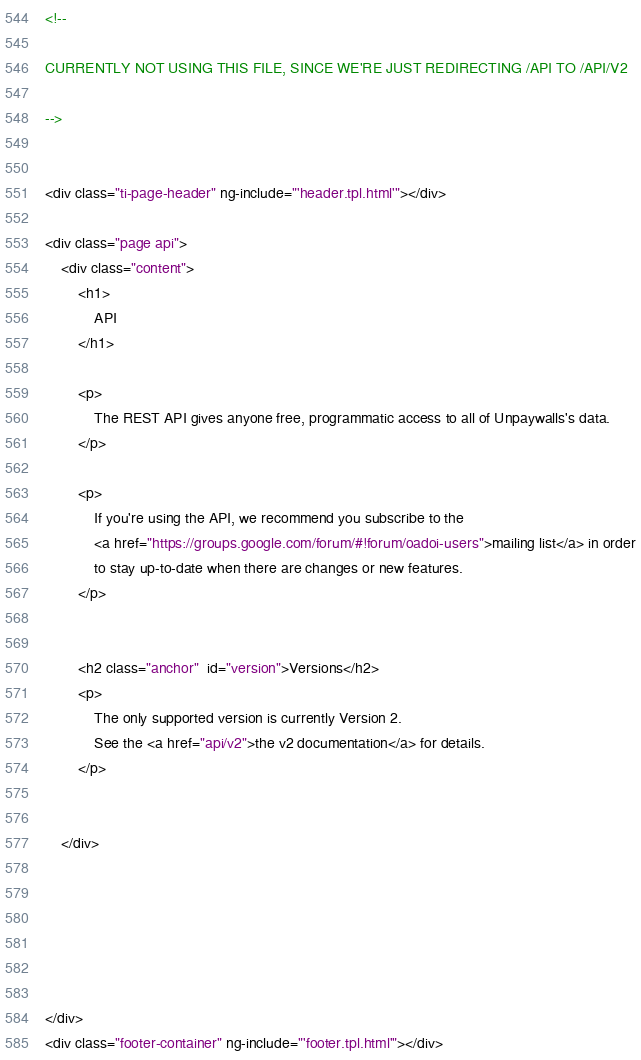<code> <loc_0><loc_0><loc_500><loc_500><_HTML_>
<!--

CURRENTLY NOT USING THIS FILE, SINCE WE'RE JUST REDIRECTING /API TO /API/V2

-->


<div class="ti-page-header" ng-include="'header.tpl.html'"></div>

<div class="page api">
    <div class="content">
        <h1>
            API
        </h1>

        <p>
            The REST API gives anyone free, programmatic access to all of Unpaywalls's data.
        </p>

        <p>
            If you're using the API, we recommend you subscribe to the
            <a href="https://groups.google.com/forum/#!forum/oadoi-users">mailing list</a> in order
            to stay up-to-date when there are changes or new features.
        </p>


        <h2 class="anchor"  id="version">Versions</h2>
        <p>
            The only supported version is currently Version 2.
            See the <a href="api/v2">the v2 documentation</a> for details.
        </p>


    </div>






</div>
<div class="footer-container" ng-include="'footer.tpl.html'"></div></code> 